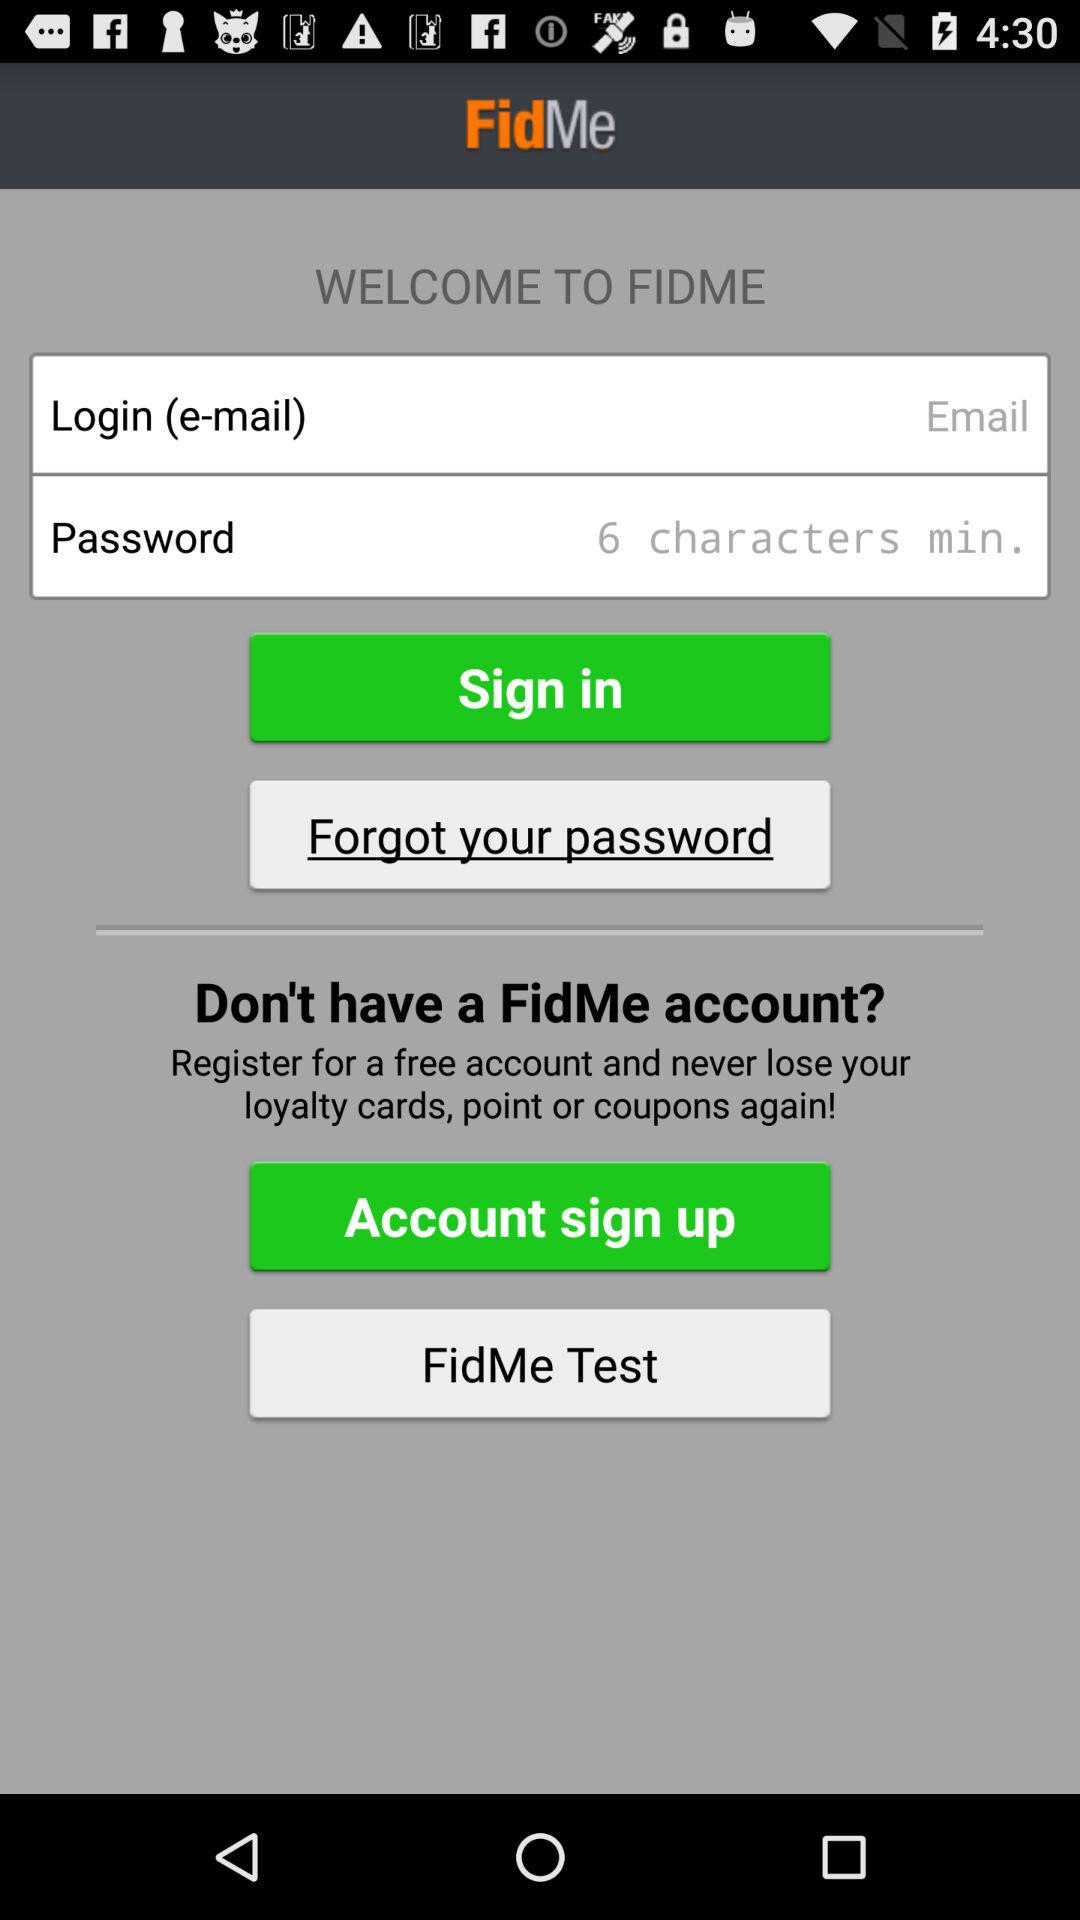How many minimum characters should be in the password? There should be a minimum of 6 characters in the password. 